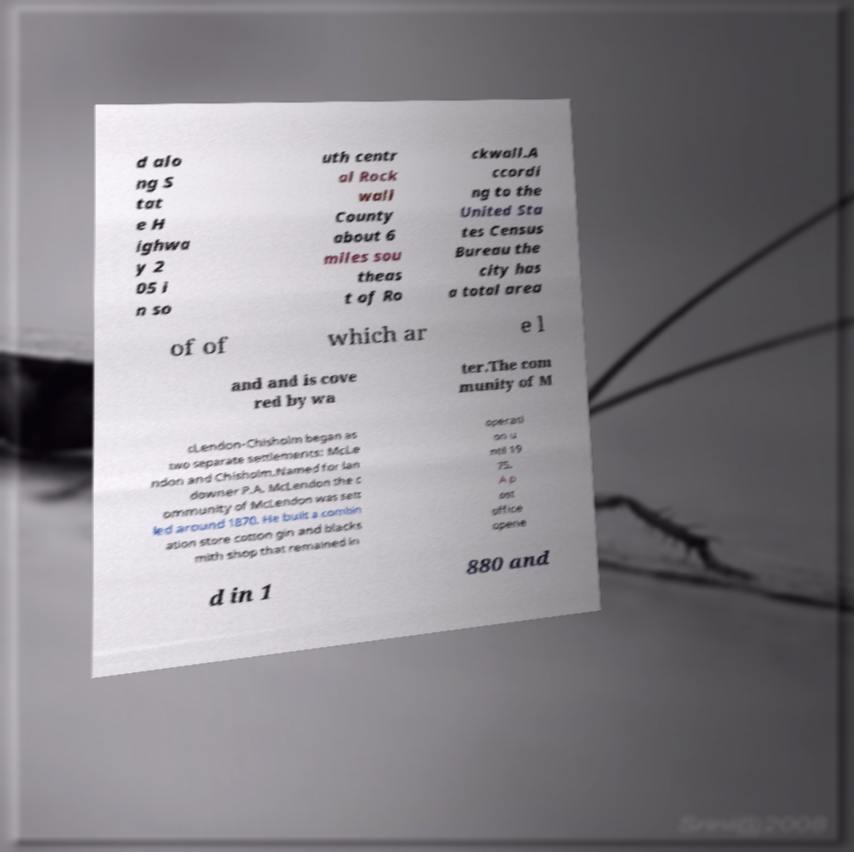Can you read and provide the text displayed in the image?This photo seems to have some interesting text. Can you extract and type it out for me? d alo ng S tat e H ighwa y 2 05 i n so uth centr al Rock wall County about 6 miles sou theas t of Ro ckwall.A ccordi ng to the United Sta tes Census Bureau the city has a total area of of which ar e l and and is cove red by wa ter.The com munity of M cLendon-Chisholm began as two separate settlements: McLe ndon and Chisholm.Named for lan downer P.A. McLendon the c ommunity of McLendon was sett led around 1870. He built a combin ation store cotton gin and blacks mith shop that remained in operati on u ntil 19 75. A p ost office opene d in 1 880 and 